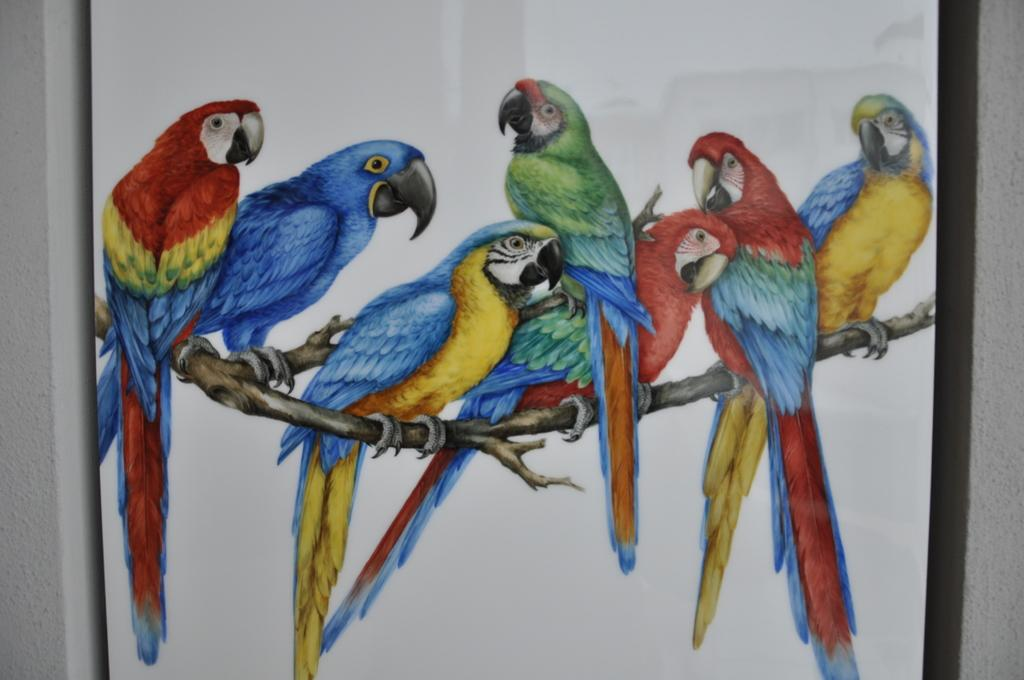What is the main object in the image? There is a board in the image. What is depicted on the board? There is a painting of birds on the board. What can be seen on either side of the board? There are walls on the left and right sides of the board. How many snakes are slithering on the board in the image? There are no snakes present in the image; the painting on the board features birds. What type of chairs can be seen surrounding the board in the image? There are no chairs visible in the image; only the board and walls are present. 